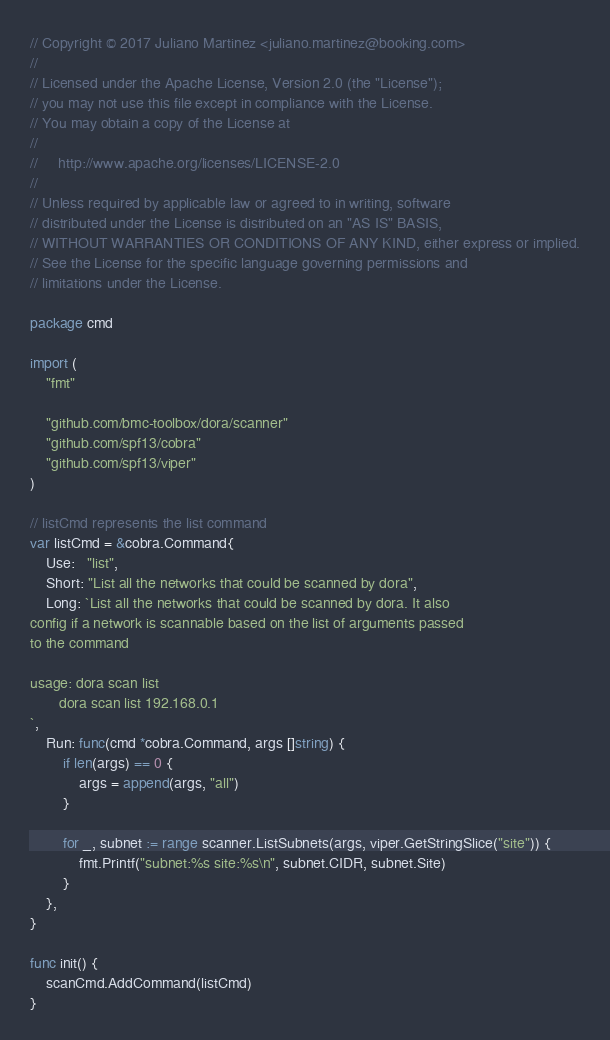Convert code to text. <code><loc_0><loc_0><loc_500><loc_500><_Go_>// Copyright © 2017 Juliano Martinez <juliano.martinez@booking.com>
//
// Licensed under the Apache License, Version 2.0 (the "License");
// you may not use this file except in compliance with the License.
// You may obtain a copy of the License at
//
//     http://www.apache.org/licenses/LICENSE-2.0
//
// Unless required by applicable law or agreed to in writing, software
// distributed under the License is distributed on an "AS IS" BASIS,
// WITHOUT WARRANTIES OR CONDITIONS OF ANY KIND, either express or implied.
// See the License for the specific language governing permissions and
// limitations under the License.

package cmd

import (
	"fmt"

	"github.com/bmc-toolbox/dora/scanner"
	"github.com/spf13/cobra"
	"github.com/spf13/viper"
)

// listCmd represents the list command
var listCmd = &cobra.Command{
	Use:   "list",
	Short: "List all the networks that could be scanned by dora",
	Long: `List all the networks that could be scanned by dora. It also
config if a network is scannable based on the list of arguments passed
to the command

usage: dora scan list
       dora scan list 192.168.0.1
`,
	Run: func(cmd *cobra.Command, args []string) {
		if len(args) == 0 {
			args = append(args, "all")
		}

		for _, subnet := range scanner.ListSubnets(args, viper.GetStringSlice("site")) {
			fmt.Printf("subnet:%s site:%s\n", subnet.CIDR, subnet.Site)
		}
	},
}

func init() {
	scanCmd.AddCommand(listCmd)
}
</code> 